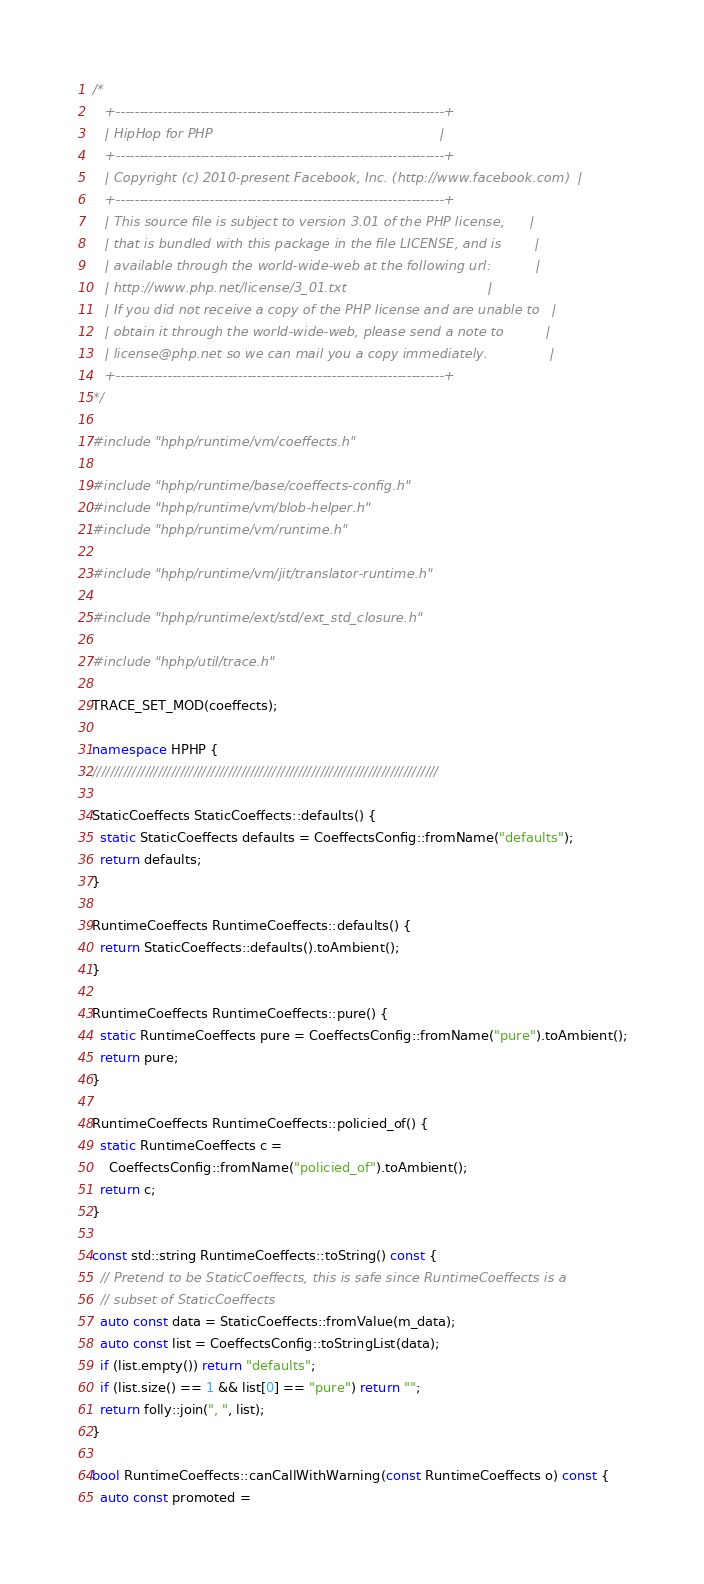<code> <loc_0><loc_0><loc_500><loc_500><_C++_>/*
   +----------------------------------------------------------------------+
   | HipHop for PHP                                                       |
   +----------------------------------------------------------------------+
   | Copyright (c) 2010-present Facebook, Inc. (http://www.facebook.com)  |
   +----------------------------------------------------------------------+
   | This source file is subject to version 3.01 of the PHP license,      |
   | that is bundled with this package in the file LICENSE, and is        |
   | available through the world-wide-web at the following url:           |
   | http://www.php.net/license/3_01.txt                                  |
   | If you did not receive a copy of the PHP license and are unable to   |
   | obtain it through the world-wide-web, please send a note to          |
   | license@php.net so we can mail you a copy immediately.               |
   +----------------------------------------------------------------------+
*/

#include "hphp/runtime/vm/coeffects.h"

#include "hphp/runtime/base/coeffects-config.h"
#include "hphp/runtime/vm/blob-helper.h"
#include "hphp/runtime/vm/runtime.h"

#include "hphp/runtime/vm/jit/translator-runtime.h"

#include "hphp/runtime/ext/std/ext_std_closure.h"

#include "hphp/util/trace.h"

TRACE_SET_MOD(coeffects);

namespace HPHP {
///////////////////////////////////////////////////////////////////////////////

StaticCoeffects StaticCoeffects::defaults() {
  static StaticCoeffects defaults = CoeffectsConfig::fromName("defaults");
  return defaults;
}

RuntimeCoeffects RuntimeCoeffects::defaults() {
  return StaticCoeffects::defaults().toAmbient();
}

RuntimeCoeffects RuntimeCoeffects::pure() {
  static RuntimeCoeffects pure = CoeffectsConfig::fromName("pure").toAmbient();
  return pure;
}

RuntimeCoeffects RuntimeCoeffects::policied_of() {
  static RuntimeCoeffects c =
    CoeffectsConfig::fromName("policied_of").toAmbient();
  return c;
}

const std::string RuntimeCoeffects::toString() const {
  // Pretend to be StaticCoeffects, this is safe since RuntimeCoeffects is a
  // subset of StaticCoeffects
  auto const data = StaticCoeffects::fromValue(m_data);
  auto const list = CoeffectsConfig::toStringList(data);
  if (list.empty()) return "defaults";
  if (list.size() == 1 && list[0] == "pure") return "";
  return folly::join(", ", list);
}

bool RuntimeCoeffects::canCallWithWarning(const RuntimeCoeffects o) const {
  auto const promoted =</code> 